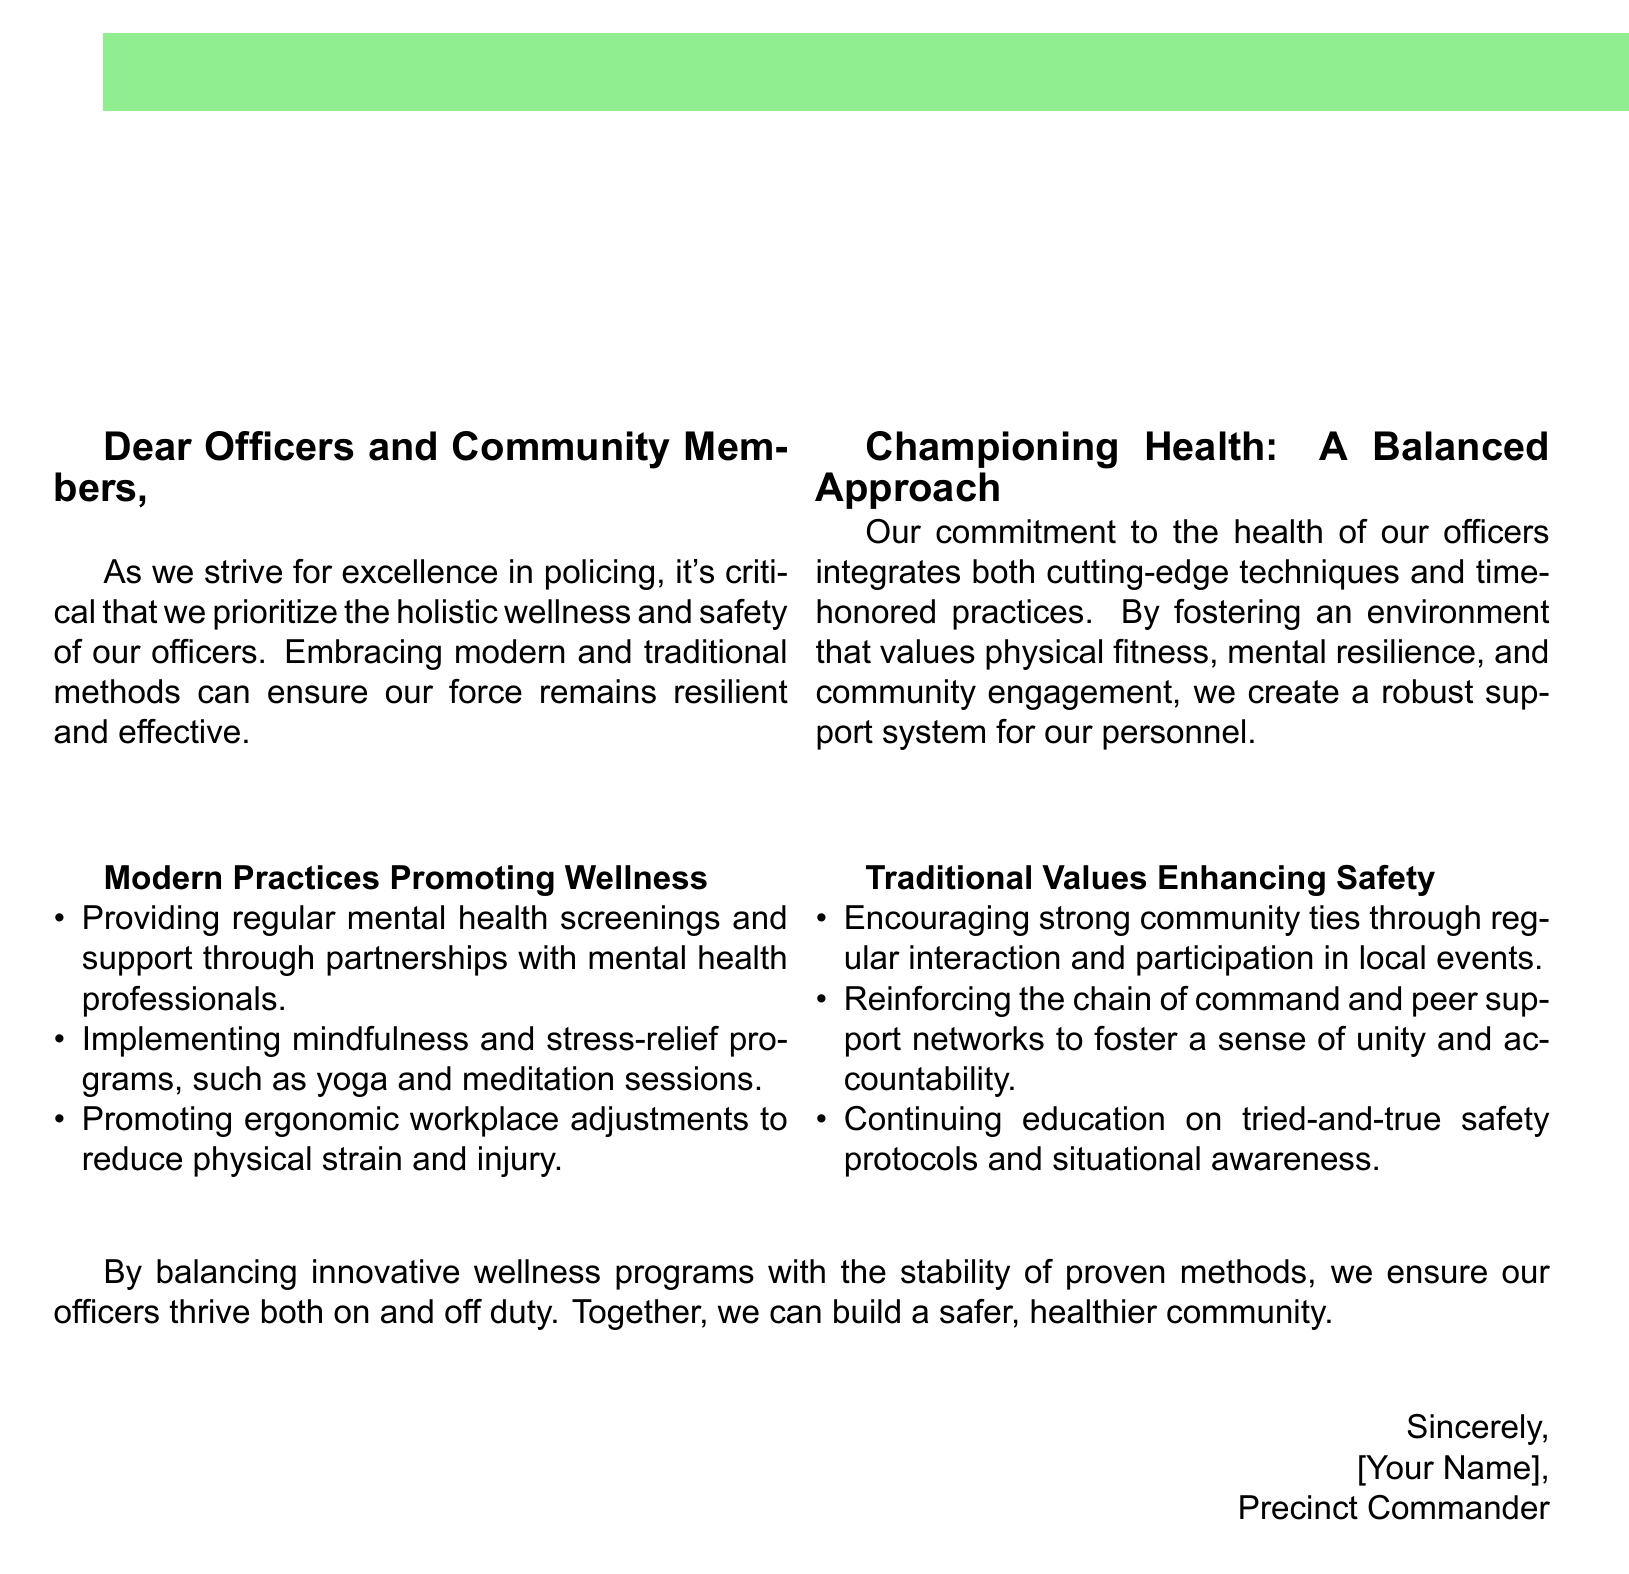What is the title on the card? The title is prominently displayed on the cover of the card as "Wellness and Safety First".
Answer: Wellness and Safety First Who is the intended audience for this card? The opening addresses "Dear Officers and Community Members," indicating that both officers and community members are involved.
Answer: Officers and Community Members What modern practice for wellness is mentioned? A specific modern practice highlighted is "mindfulness and stress-relief programs, such as yoga and meditation sessions."
Answer: mindfulness and stress-relief programs What traditional value is emphasized in the document? The card points out "Encouraging strong community ties through regular interaction and participation in local events" as a traditional value.
Answer: Encouraging strong community ties What is the overall purpose of this greeting card? The greeting card seeks to promote the health and safety of police officers through both modern and traditional methods.
Answer: Promote health and safety of police officers Who signs the card? The card is signed off by "[Your Name], Precinct Commander," indicating the authority of the sender.
Answer: [Your Name], Precinct Commander What color is used for the header background? The header background of the card uses a specific color defined in the document, which is referred to as "policebadge".
Answer: policebadge What element represents community engagement? The document highlights "participation in local events" as a way to enhance community engagement.
Answer: participation in local events 